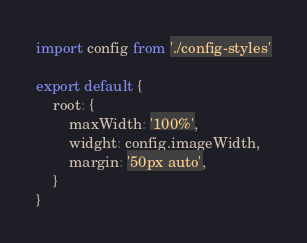Convert code to text. <code><loc_0><loc_0><loc_500><loc_500><_JavaScript_>import config from './config-styles'

export default {
    root: {
        maxWidth: '100%',
        widght: config.imageWidth,
        margin: '50px auto',
    }
}</code> 